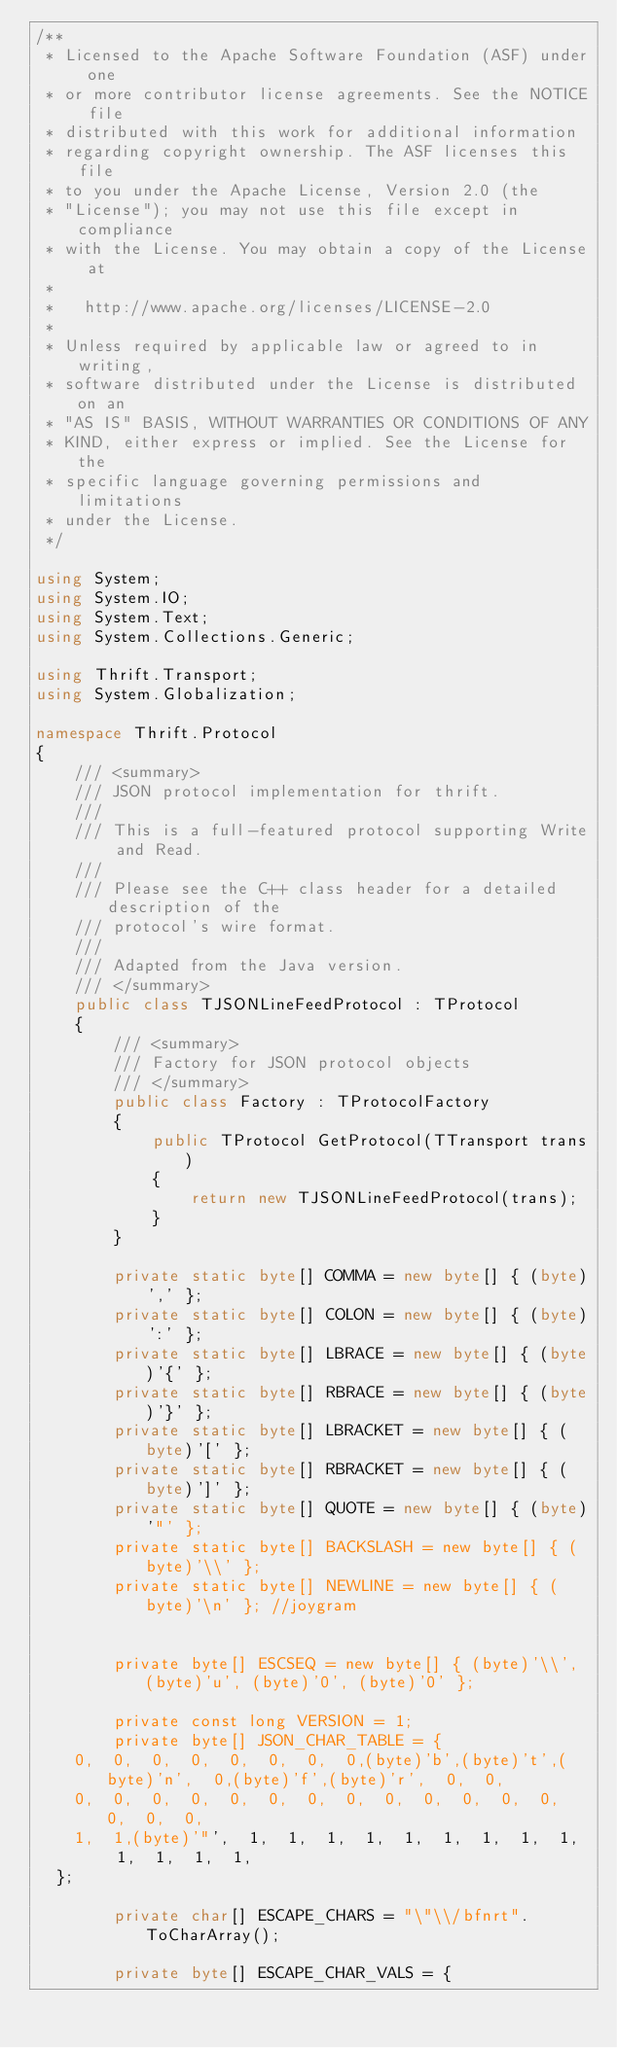Convert code to text. <code><loc_0><loc_0><loc_500><loc_500><_C#_>/**
 * Licensed to the Apache Software Foundation (ASF) under one
 * or more contributor license agreements. See the NOTICE file
 * distributed with this work for additional information
 * regarding copyright ownership. The ASF licenses this file
 * to you under the Apache License, Version 2.0 (the
 * "License"); you may not use this file except in compliance
 * with the License. You may obtain a copy of the License at
 *
 *   http://www.apache.org/licenses/LICENSE-2.0
 *
 * Unless required by applicable law or agreed to in writing,
 * software distributed under the License is distributed on an
 * "AS IS" BASIS, WITHOUT WARRANTIES OR CONDITIONS OF ANY
 * KIND, either express or implied. See the License for the
 * specific language governing permissions and limitations
 * under the License.
 */

using System;
using System.IO;
using System.Text;
using System.Collections.Generic;

using Thrift.Transport;
using System.Globalization;

namespace Thrift.Protocol
{
    /// <summary>
    /// JSON protocol implementation for thrift.
    ///
    /// This is a full-featured protocol supporting Write and Read.
    ///
    /// Please see the C++ class header for a detailed description of the
    /// protocol's wire format.
    ///
    /// Adapted from the Java version.
    /// </summary>
    public class TJSONLineFeedProtocol : TProtocol
    {
        /// <summary>
        /// Factory for JSON protocol objects
        /// </summary>
        public class Factory : TProtocolFactory
        {
            public TProtocol GetProtocol(TTransport trans)
            {
                return new TJSONLineFeedProtocol(trans);
            }
        }

        private static byte[] COMMA = new byte[] { (byte)',' };
        private static byte[] COLON = new byte[] { (byte)':' };
        private static byte[] LBRACE = new byte[] { (byte)'{' };
        private static byte[] RBRACE = new byte[] { (byte)'}' };
        private static byte[] LBRACKET = new byte[] { (byte)'[' };
        private static byte[] RBRACKET = new byte[] { (byte)']' };
        private static byte[] QUOTE = new byte[] { (byte)'"' };
        private static byte[] BACKSLASH = new byte[] { (byte)'\\' };
        private static byte[] NEWLINE = new byte[] { (byte)'\n' }; //joygram


        private byte[] ESCSEQ = new byte[] { (byte)'\\', (byte)'u', (byte)'0', (byte)'0' };

        private const long VERSION = 1;
        private byte[] JSON_CHAR_TABLE = {
    0,  0,  0,  0,  0,  0,  0,  0,(byte)'b',(byte)'t',(byte)'n',  0,(byte)'f',(byte)'r',  0,  0,
    0,  0,  0,  0,  0,  0,  0,  0,  0,  0,  0,  0,  0,  0,  0,  0,
    1,  1,(byte)'"',  1,  1,  1,  1,  1,  1,  1,  1,  1,  1,  1,  1,  1,
  };

        private char[] ESCAPE_CHARS = "\"\\/bfnrt".ToCharArray();

        private byte[] ESCAPE_CHAR_VALS = {</code> 